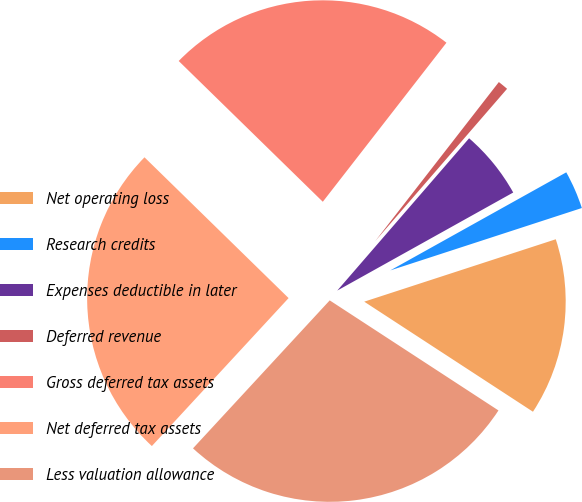Convert chart. <chart><loc_0><loc_0><loc_500><loc_500><pie_chart><fcel>Net operating loss<fcel>Research credits<fcel>Expenses deductible in later<fcel>Deferred revenue<fcel>Gross deferred tax assets<fcel>Net deferred tax assets<fcel>Less valuation allowance<nl><fcel>14.21%<fcel>3.08%<fcel>5.55%<fcel>0.84%<fcel>23.2%<fcel>25.44%<fcel>27.67%<nl></chart> 